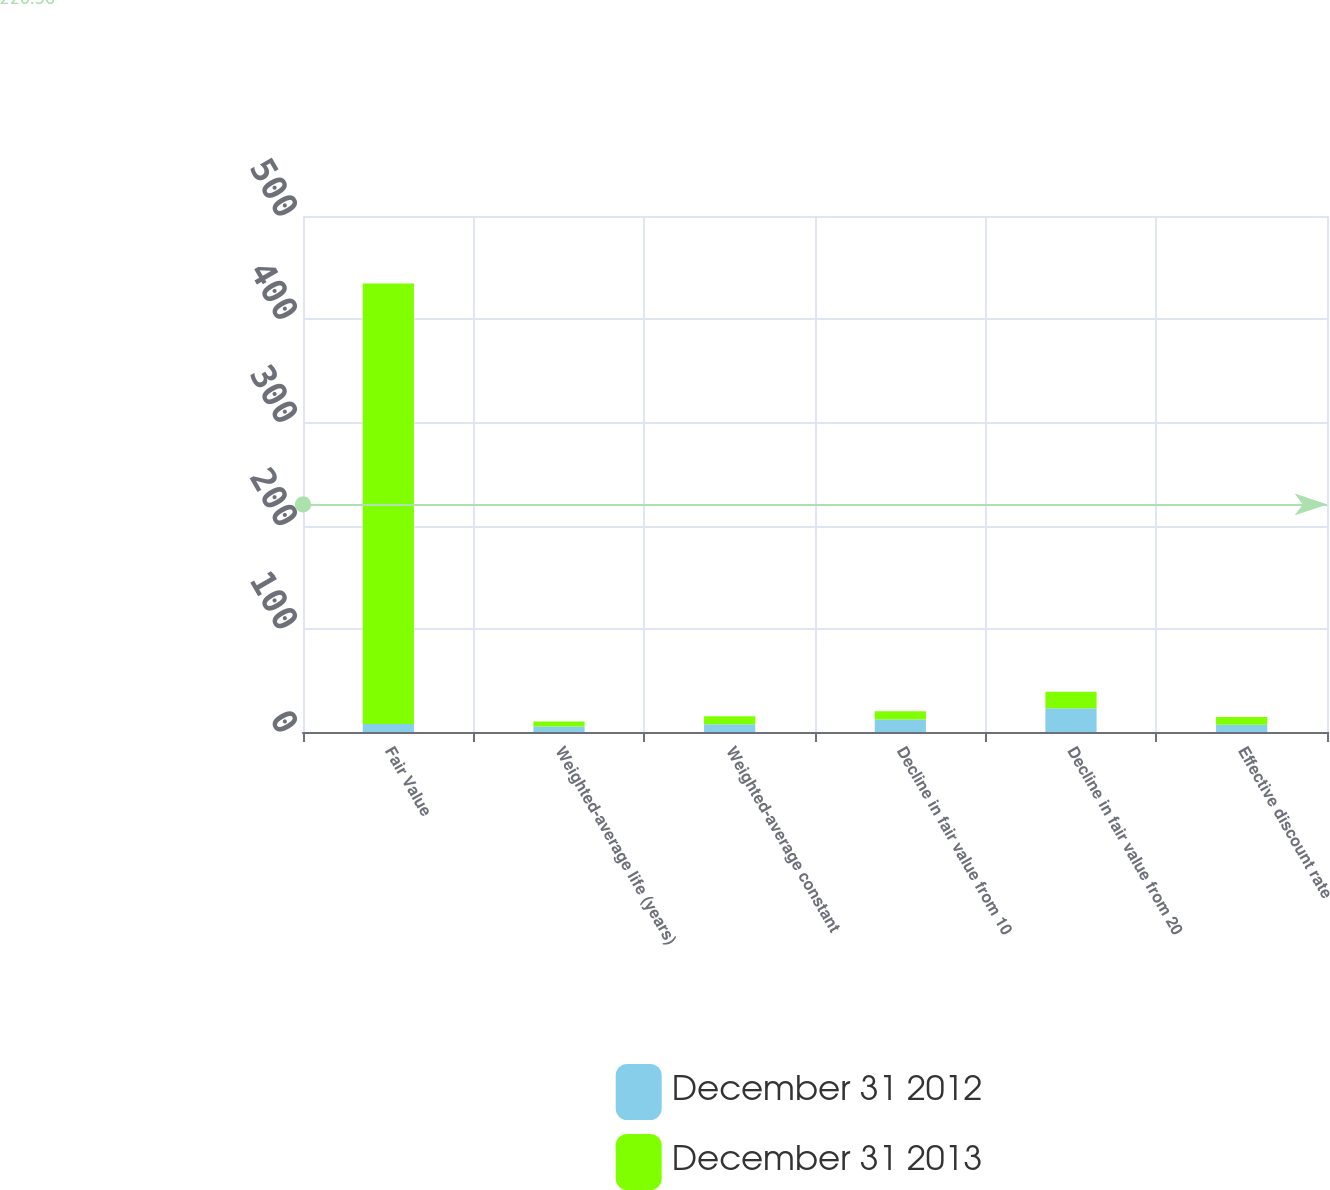Convert chart. <chart><loc_0><loc_0><loc_500><loc_500><stacked_bar_chart><ecel><fcel>Fair Value<fcel>Weighted-average life (years)<fcel>Weighted-average constant<fcel>Decline in fair value from 10<fcel>Decline in fair value from 20<fcel>Effective discount rate<nl><fcel>December 31 2012<fcel>7.7<fcel>5.3<fcel>7.52<fcel>12<fcel>23<fcel>6.91<nl><fcel>December 31 2013<fcel>427<fcel>4.8<fcel>7.63<fcel>8<fcel>16<fcel>7.7<nl></chart> 